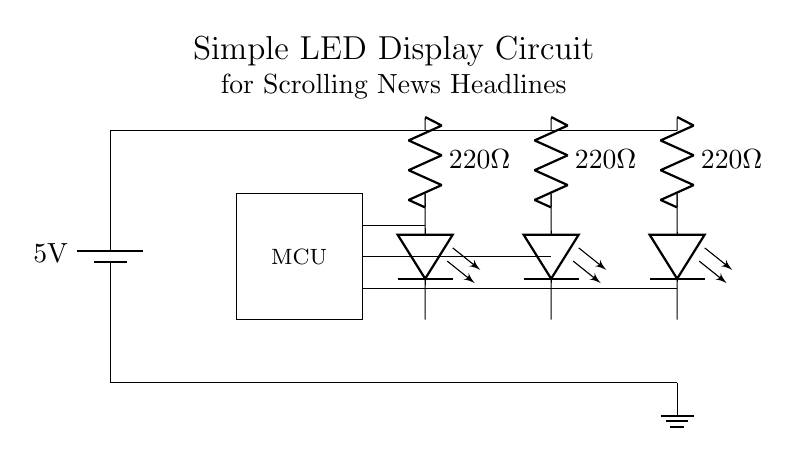What is the voltage of this circuit? The voltage is 5V, which is indicated by the battery symbol at the top left corner of the circuit diagram.
Answer: 5V How many LEDs are in this circuit? There are three LEDs, which can be seen at the positions labeled with the LED symbol.
Answer: Three What is the resistance value of each resistor? Each resistor has a resistance value of 220 ohms, as stated next to each resistor symbol in the diagram.
Answer: 220 ohms Which component acts as the control unit in this circuit? The microcontroller is the control unit, indicated by the labeled rectangle in the circuit diagram.
Answer: MCU What connects the power supply and the ground? The circuit has wires connecting the power supply to the components and then to the ground symbol at the bottom right.
Answer: Wires What is the function of the resistors in this circuit? The resistors are used to limit the current to the LEDs, protecting them from too much current that could cause damage.
Answer: Current limiter 